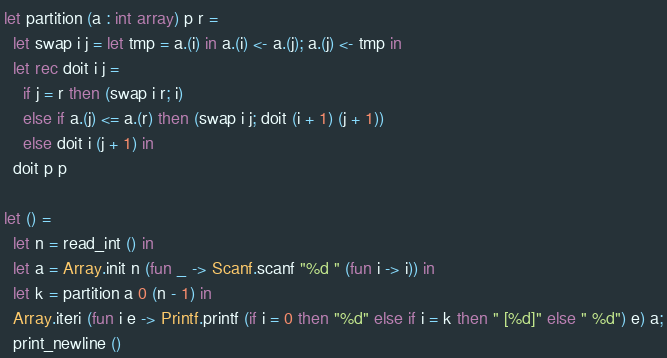Convert code to text. <code><loc_0><loc_0><loc_500><loc_500><_OCaml_>let partition (a : int array) p r =
  let swap i j = let tmp = a.(i) in a.(i) <- a.(j); a.(j) <- tmp in
  let rec doit i j =
    if j = r then (swap i r; i)
    else if a.(j) <= a.(r) then (swap i j; doit (i + 1) (j + 1))
    else doit i (j + 1) in
  doit p p

let () =
  let n = read_int () in
  let a = Array.init n (fun _ -> Scanf.scanf "%d " (fun i -> i)) in
  let k = partition a 0 (n - 1) in
  Array.iteri (fun i e -> Printf.printf (if i = 0 then "%d" else if i = k then " [%d]" else " %d") e) a;
  print_newline ()</code> 